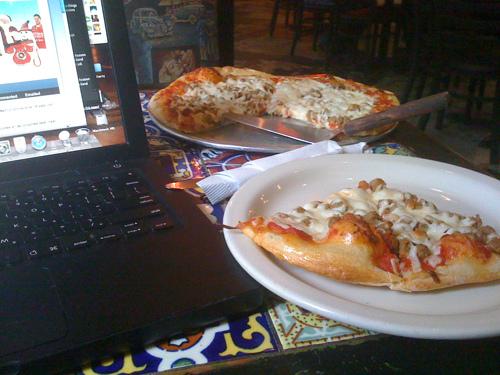What is on the plate?
Be succinct. Pizza. What color is the plate?
Write a very short answer. White. What red thing is on the computer screen?
Give a very brief answer. Telephone. 